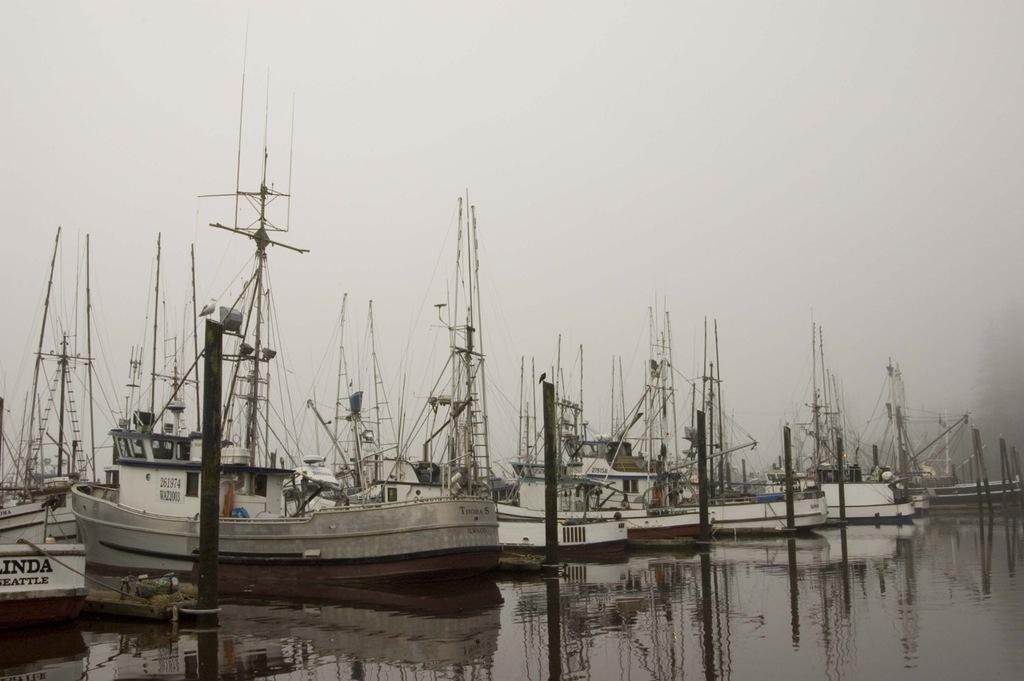Is there letters before the inda on the boat on the far left?
Give a very brief answer. Unanswerable. 